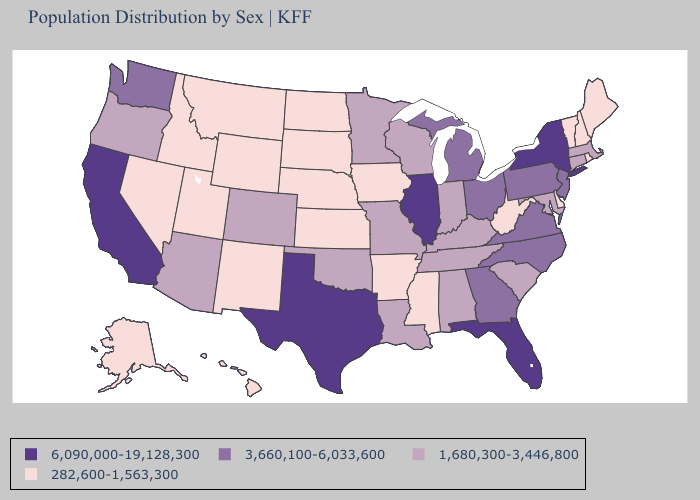What is the lowest value in the USA?
Quick response, please. 282,600-1,563,300. Does Virginia have the same value as Vermont?
Be succinct. No. Does Connecticut have a higher value than Indiana?
Answer briefly. No. What is the value of Alabama?
Keep it brief. 1,680,300-3,446,800. What is the lowest value in the Northeast?
Quick response, please. 282,600-1,563,300. What is the lowest value in the USA?
Quick response, please. 282,600-1,563,300. Which states have the lowest value in the USA?
Quick response, please. Alaska, Arkansas, Delaware, Hawaii, Idaho, Iowa, Kansas, Maine, Mississippi, Montana, Nebraska, Nevada, New Hampshire, New Mexico, North Dakota, Rhode Island, South Dakota, Utah, Vermont, West Virginia, Wyoming. Which states have the highest value in the USA?
Be succinct. California, Florida, Illinois, New York, Texas. What is the lowest value in states that border North Carolina?
Answer briefly. 1,680,300-3,446,800. Does Florida have the highest value in the South?
Quick response, please. Yes. What is the lowest value in the USA?
Answer briefly. 282,600-1,563,300. What is the lowest value in the West?
Concise answer only. 282,600-1,563,300. Which states have the lowest value in the West?
Write a very short answer. Alaska, Hawaii, Idaho, Montana, Nevada, New Mexico, Utah, Wyoming. What is the lowest value in the USA?
Keep it brief. 282,600-1,563,300. 